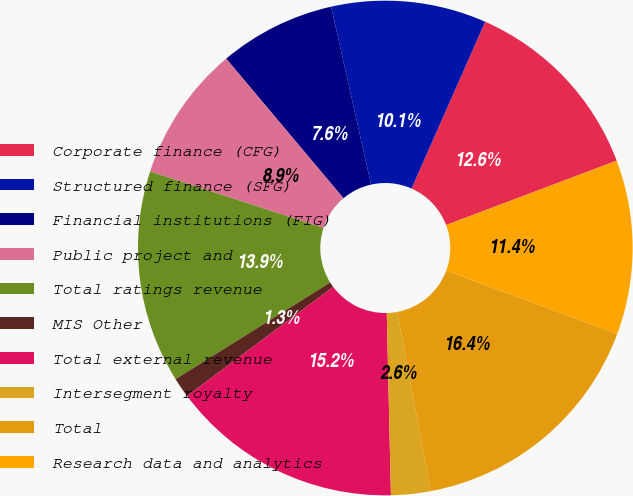Convert chart to OTSL. <chart><loc_0><loc_0><loc_500><loc_500><pie_chart><fcel>Corporate finance (CFG)<fcel>Structured finance (SFG)<fcel>Financial institutions (FIG)<fcel>Public project and<fcel>Total ratings revenue<fcel>MIS Other<fcel>Total external revenue<fcel>Intersegment royalty<fcel>Total<fcel>Research data and analytics<nl><fcel>12.64%<fcel>10.13%<fcel>7.61%<fcel>8.87%<fcel>13.9%<fcel>1.31%<fcel>15.16%<fcel>2.57%<fcel>16.42%<fcel>11.39%<nl></chart> 